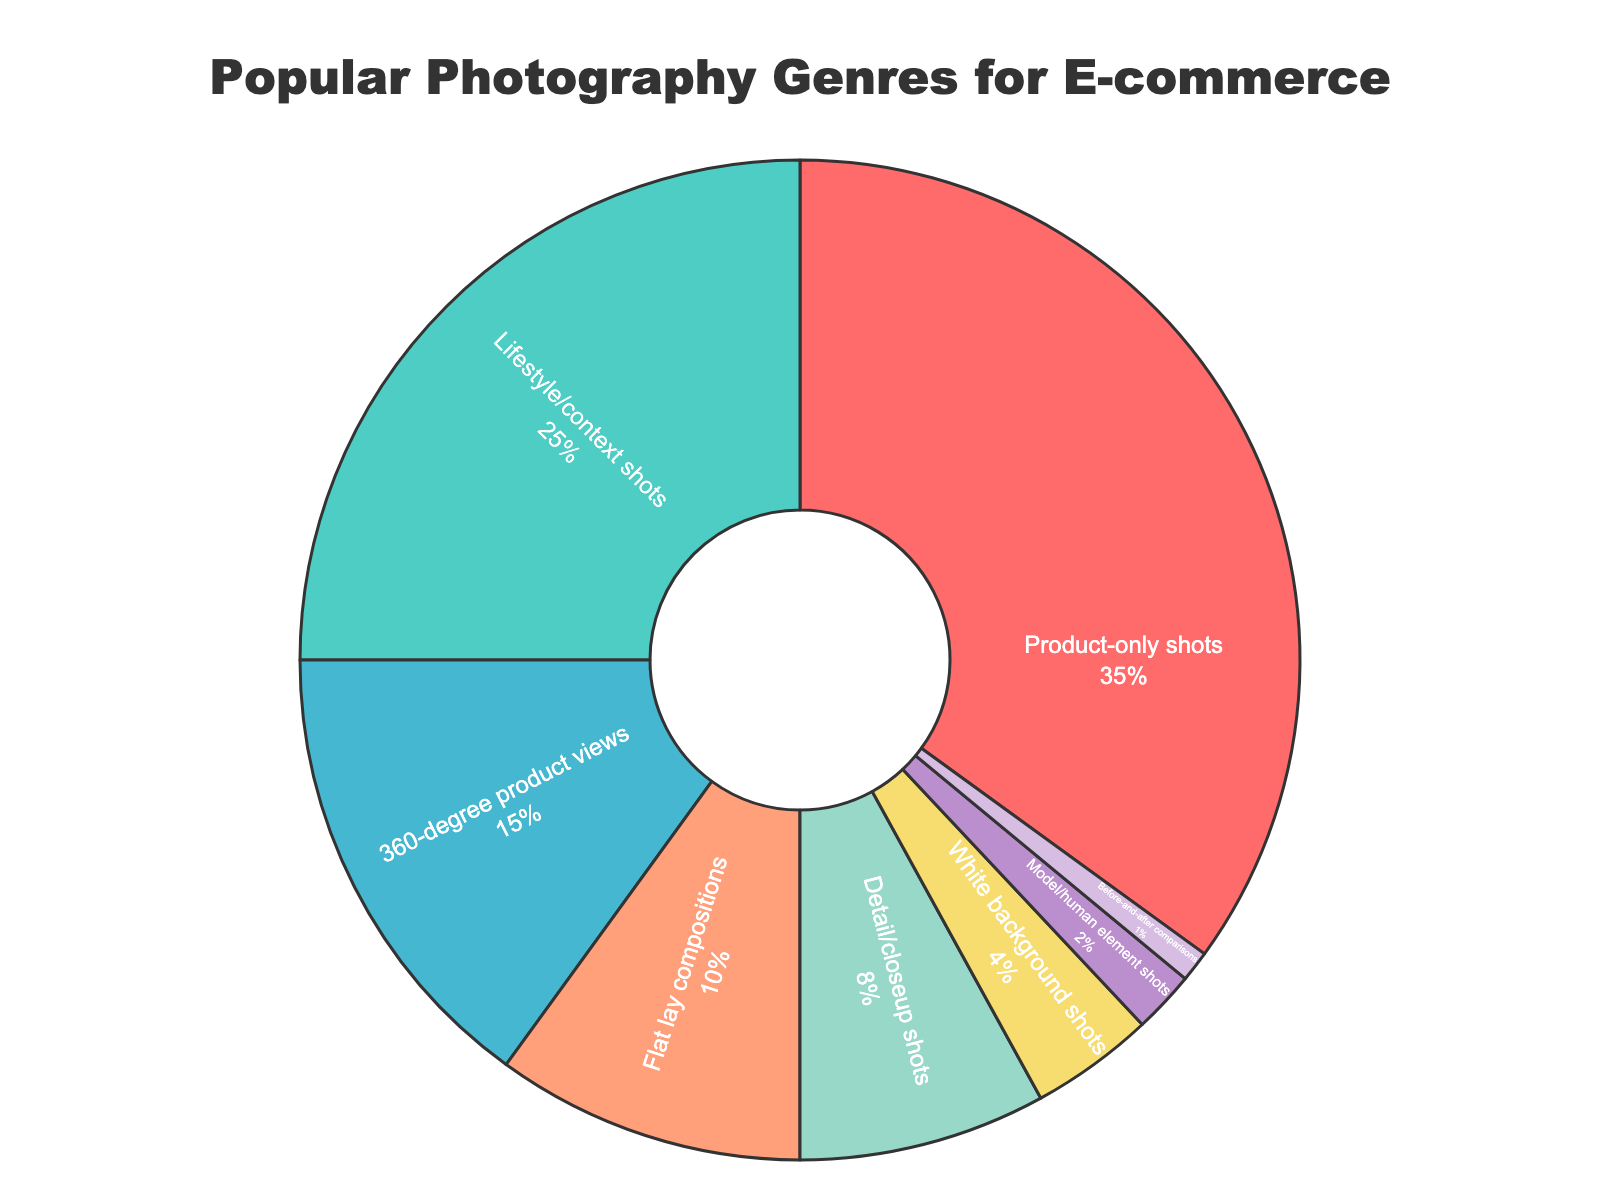What percentage of the total is captured by the two most popular genres? First, identify the two most popular genres, which are "Product-only shots" (35%) and "Lifestyle/context shots" (25%). Add these percentages together: 35% + 25% = 60%.
Answer: 60% Which genre has the smallest representation in the chart? By what percentage is it smaller than the Product-only shots genre? The genre with the smallest representation is "Before-and-after comparisons" at 1%. To compare with "Product-only shots" at 35%, subtract the smaller percentage from the larger percentage: 35% - 1% = 34%.
Answer: Before-and-after comparisons, 34% How does the percentage of "360-degree product views" compare to "Flat lay compositions"? "360-degree product views" account for 15%, while "Flat lay compositions" account for 10%. Comparing these, 15% - 10% = 5%, which means "360-degree product views" have 5% more than "Flat lay compositions".
Answer: 5% more Which genres together make up more than half of the pie chart? To find this, sum the percentages starting from the highest until the sum exceeds 50%. "Product-only shots" (35%) + "Lifestyle/context shots" (25%) = 60%, which is more than half.
Answer: Product-only shots, Lifestyle/context shots What's the combined percentage of "Detail/closeup shots", "White background shots", and "Model/human element shots"? Sum the percentages of these categories: "Detail/closeup shots" (8%) + "White background shots" (4%) + "Model/human element shots" (2%) = 8% + 4% + 2% = 14%.
Answer: 14% What is the difference in representation between "Lifestyle/context shots" and "Detail/closeup shots"? "Lifestyle/context shots" represent 25% and "Detail/closeup shots" represent 8%. The difference is 25% - 8% = 17%.
Answer: 17% Among the genres labeled with percentages, which are represented by lighter colors and what are their percentages? "Product-only shots" (35%) is in red, "Lifestyle/context shots" (25%) is in green, and "360-degree product views" (15%) is in blue, these are visually more distinct and use lighter/more prominent colors compared to others.
Answer: Product-only shots: 35%, Lifestyle/context shots: 25%, 360-degree product views: 15% What is the total percentage covered by genres related to the presence of human elements (e.g., "Model/human element shots")? Identify relevant genres: "Lifestyle/context shots" (25%) and "Model/human element shots" (2%). Sum these percentages: 25% + 2% = 27%.
Answer: 27% 